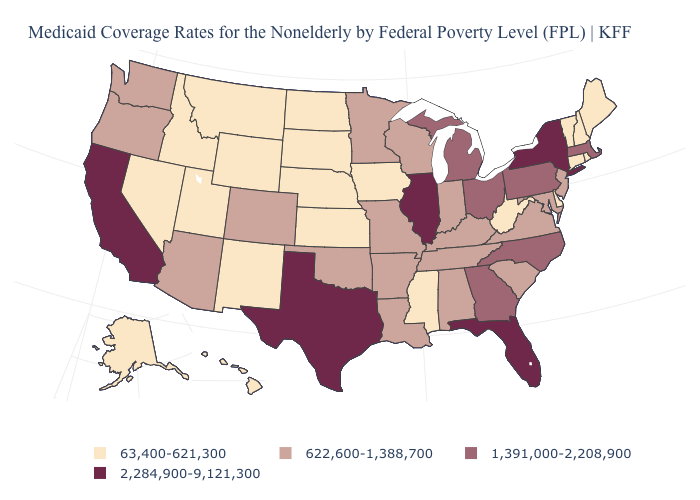How many symbols are there in the legend?
Keep it brief. 4. What is the value of North Carolina?
Give a very brief answer. 1,391,000-2,208,900. What is the value of Hawaii?
Be succinct. 63,400-621,300. What is the highest value in the USA?
Be succinct. 2,284,900-9,121,300. Does Texas have the highest value in the USA?
Write a very short answer. Yes. Name the states that have a value in the range 622,600-1,388,700?
Short answer required. Alabama, Arizona, Arkansas, Colorado, Indiana, Kentucky, Louisiana, Maryland, Minnesota, Missouri, New Jersey, Oklahoma, Oregon, South Carolina, Tennessee, Virginia, Washington, Wisconsin. Name the states that have a value in the range 1,391,000-2,208,900?
Short answer required. Georgia, Massachusetts, Michigan, North Carolina, Ohio, Pennsylvania. What is the value of South Carolina?
Answer briefly. 622,600-1,388,700. Which states hav the highest value in the West?
Write a very short answer. California. What is the lowest value in the Northeast?
Write a very short answer. 63,400-621,300. Among the states that border California , does Nevada have the highest value?
Quick response, please. No. What is the value of Minnesota?
Be succinct. 622,600-1,388,700. What is the lowest value in the South?
Quick response, please. 63,400-621,300. Name the states that have a value in the range 2,284,900-9,121,300?
Short answer required. California, Florida, Illinois, New York, Texas. Does the map have missing data?
Concise answer only. No. 